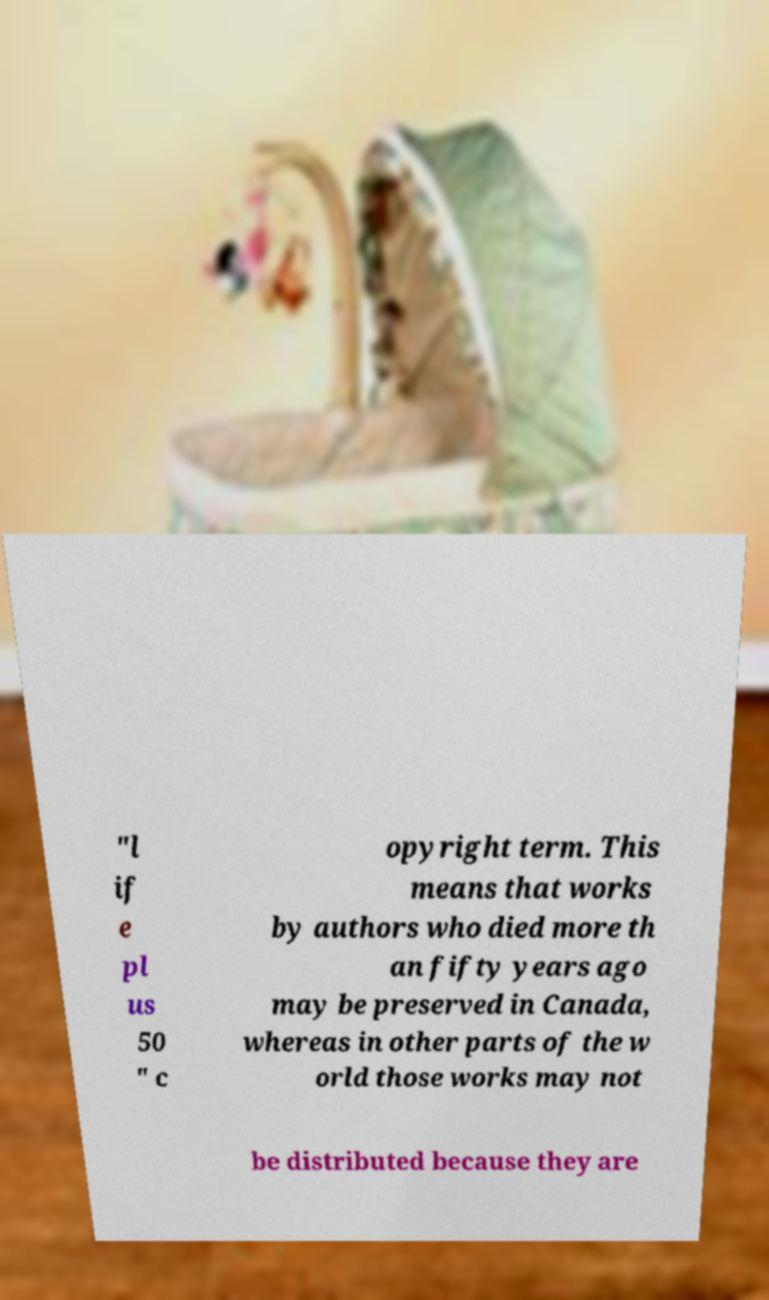I need the written content from this picture converted into text. Can you do that? "l if e pl us 50 " c opyright term. This means that works by authors who died more th an fifty years ago may be preserved in Canada, whereas in other parts of the w orld those works may not be distributed because they are 